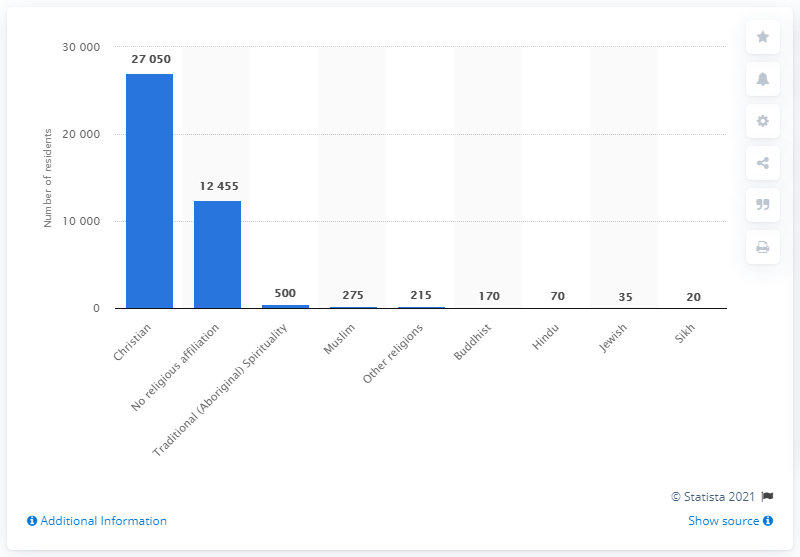Give some essential details in this illustration. According to a survey conducted in 2011, approximately 27,000 Canadian citizens and permanent/non-permanent residents living in the Northwest Territories identified as Christian. 